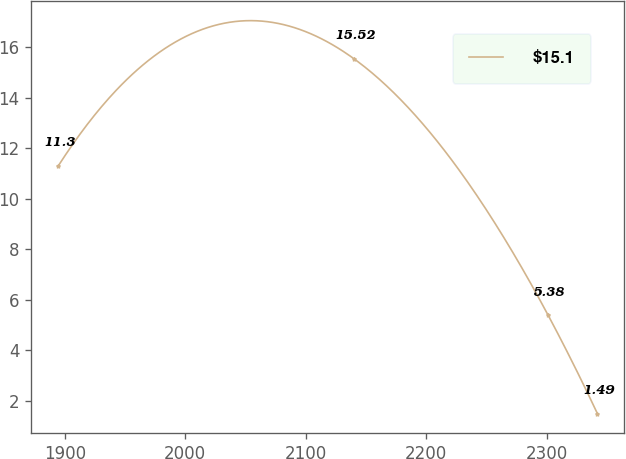Convert chart to OTSL. <chart><loc_0><loc_0><loc_500><loc_500><line_chart><ecel><fcel>$15.1<nl><fcel>1894.67<fcel>11.3<nl><fcel>2140.39<fcel>15.52<nl><fcel>2301.18<fcel>5.38<nl><fcel>2342.04<fcel>1.49<nl></chart> 